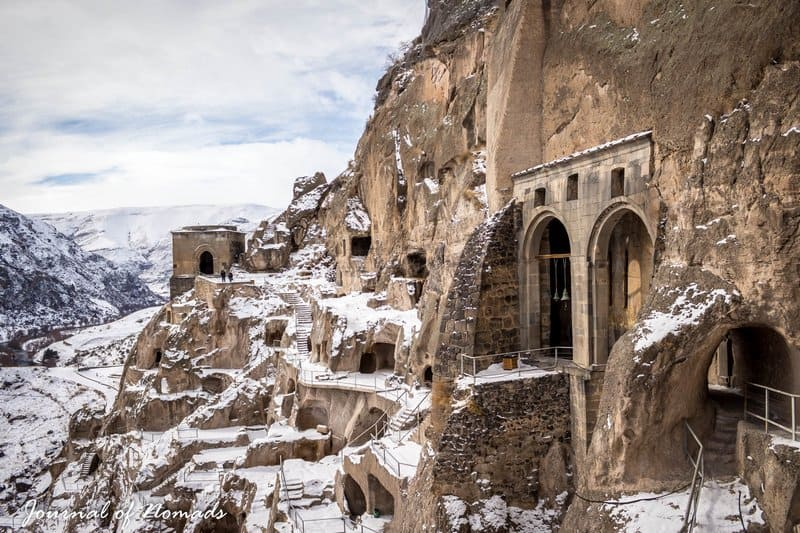Describe the following image. The image showcases the incredible architectural wonder of the Vardzia cave monastery in Georgia, ingeniously carved into the cliffside. A blanket of snow covers the rugged terrain, enhancing the stark contrast between nature and the handcrafted structures. The overcast sky softens the ambient light, highlighting the intricate layers, arches, and openings of the monastery. The image also offers glimpses of the ruins in the distant background, adding a layer of mystery and storytelling about the site's historical battles and past civilizations. This snapshot captures not just the physical grandeur but also the spiritual and historical resonance of the location. 